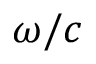<formula> <loc_0><loc_0><loc_500><loc_500>\omega / c</formula> 